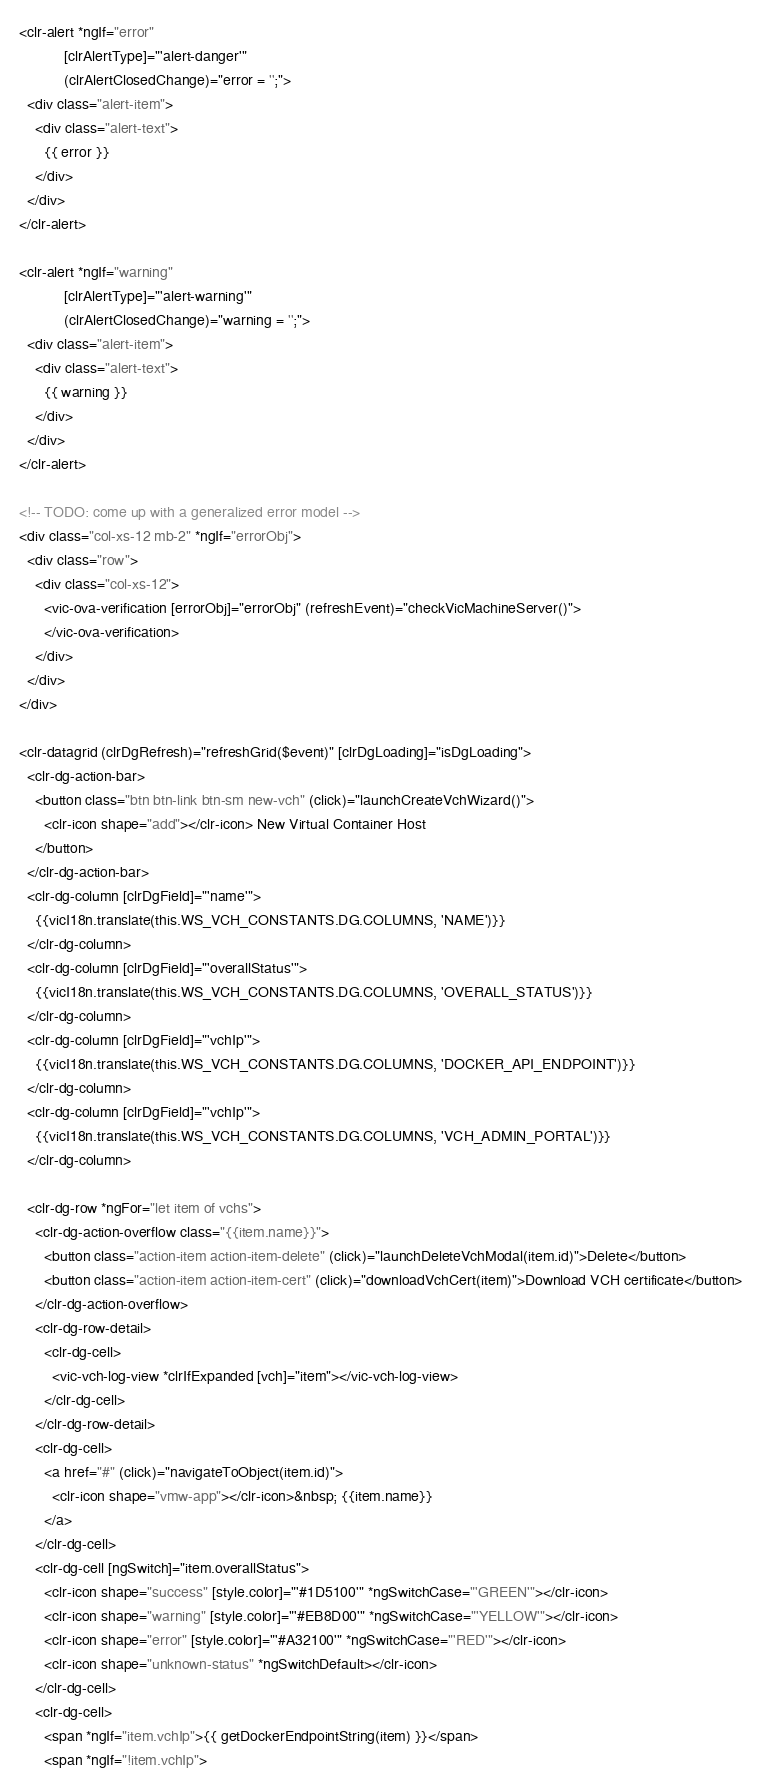Convert code to text. <code><loc_0><loc_0><loc_500><loc_500><_HTML_><clr-alert *ngIf="error"
           [clrAlertType]="'alert-danger'"
           (clrAlertClosedChange)="error = '';">
  <div class="alert-item">
    <div class="alert-text">
      {{ error }}
    </div>
  </div>
</clr-alert>

<clr-alert *ngIf="warning"
           [clrAlertType]="'alert-warning'"
           (clrAlertClosedChange)="warning = '';">
  <div class="alert-item">
    <div class="alert-text">
      {{ warning }}
    </div>
  </div>
</clr-alert>

<!-- TODO: come up with a generalized error model -->
<div class="col-xs-12 mb-2" *ngIf="errorObj">
  <div class="row">
    <div class="col-xs-12">
      <vic-ova-verification [errorObj]="errorObj" (refreshEvent)="checkVicMachineServer()">
      </vic-ova-verification>
    </div>
  </div>
</div>

<clr-datagrid (clrDgRefresh)="refreshGrid($event)" [clrDgLoading]="isDgLoading">
  <clr-dg-action-bar>
    <button class="btn btn-link btn-sm new-vch" (click)="launchCreateVchWizard()">
      <clr-icon shape="add"></clr-icon> New Virtual Container Host
    </button>
  </clr-dg-action-bar>
  <clr-dg-column [clrDgField]="'name'">
    {{vicI18n.translate(this.WS_VCH_CONSTANTS.DG.COLUMNS, 'NAME')}}
  </clr-dg-column>
  <clr-dg-column [clrDgField]="'overallStatus'">
    {{vicI18n.translate(this.WS_VCH_CONSTANTS.DG.COLUMNS, 'OVERALL_STATUS')}}
  </clr-dg-column>
  <clr-dg-column [clrDgField]="'vchIp'">
    {{vicI18n.translate(this.WS_VCH_CONSTANTS.DG.COLUMNS, 'DOCKER_API_ENDPOINT')}}
  </clr-dg-column>
  <clr-dg-column [clrDgField]="'vchIp'">
    {{vicI18n.translate(this.WS_VCH_CONSTANTS.DG.COLUMNS, 'VCH_ADMIN_PORTAL')}}
  </clr-dg-column>

  <clr-dg-row *ngFor="let item of vchs">
    <clr-dg-action-overflow class="{{item.name}}">
      <button class="action-item action-item-delete" (click)="launchDeleteVchModal(item.id)">Delete</button>
      <button class="action-item action-item-cert" (click)="downloadVchCert(item)">Download VCH certificate</button>
    </clr-dg-action-overflow>
    <clr-dg-row-detail>
      <clr-dg-cell>
        <vic-vch-log-view *clrIfExpanded [vch]="item"></vic-vch-log-view>
      </clr-dg-cell>
    </clr-dg-row-detail>
    <clr-dg-cell>
      <a href="#" (click)="navigateToObject(item.id)">
        <clr-icon shape="vmw-app"></clr-icon>&nbsp; {{item.name}}
      </a>
    </clr-dg-cell>
    <clr-dg-cell [ngSwitch]="item.overallStatus">
      <clr-icon shape="success" [style.color]="'#1D5100'" *ngSwitchCase="'GREEN'"></clr-icon>
      <clr-icon shape="warning" [style.color]="'#EB8D00'" *ngSwitchCase="'YELLOW'"></clr-icon>
      <clr-icon shape="error" [style.color]="'#A32100'" *ngSwitchCase="'RED'"></clr-icon>
      <clr-icon shape="unknown-status" *ngSwitchDefault></clr-icon>
    </clr-dg-cell>
    <clr-dg-cell>
      <span *ngIf="item.vchIp">{{ getDockerEndpointString(item) }}</span>
      <span *ngIf="!item.vchIp"></code> 